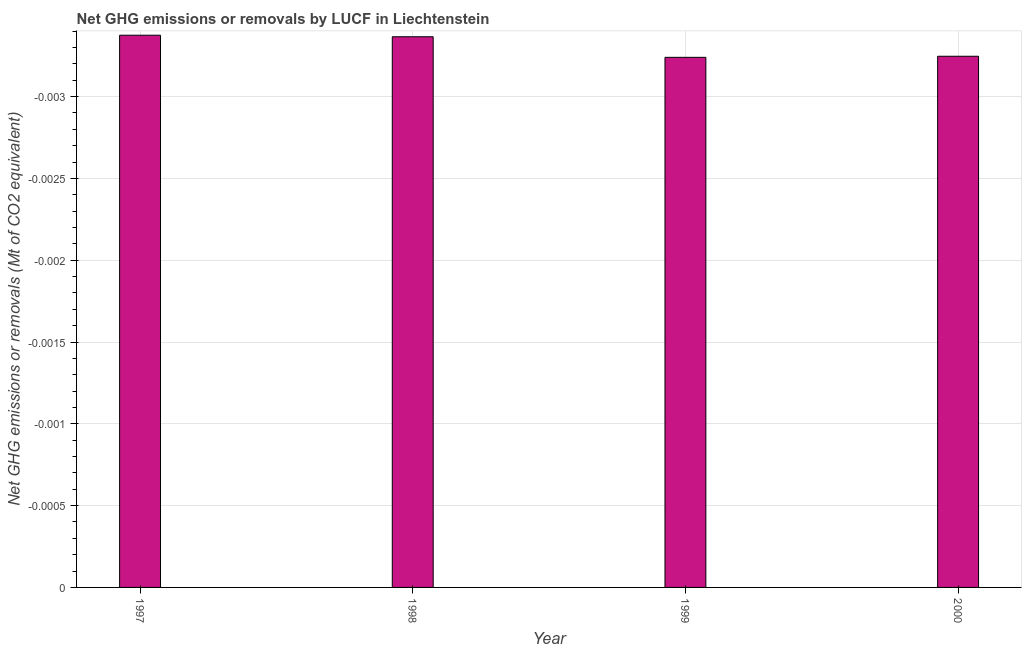Does the graph contain any zero values?
Provide a succinct answer. Yes. Does the graph contain grids?
Provide a short and direct response. Yes. What is the title of the graph?
Keep it short and to the point. Net GHG emissions or removals by LUCF in Liechtenstein. What is the label or title of the Y-axis?
Provide a succinct answer. Net GHG emissions or removals (Mt of CO2 equivalent). What is the ghg net emissions or removals in 1999?
Ensure brevity in your answer.  0. Across all years, what is the minimum ghg net emissions or removals?
Your response must be concise. 0. What is the median ghg net emissions or removals?
Make the answer very short. 0. In how many years, is the ghg net emissions or removals greater than the average ghg net emissions or removals taken over all years?
Give a very brief answer. 0. Are all the bars in the graph horizontal?
Keep it short and to the point. No. What is the difference between two consecutive major ticks on the Y-axis?
Offer a very short reply. 0. What is the Net GHG emissions or removals (Mt of CO2 equivalent) in 1999?
Offer a terse response. 0. What is the Net GHG emissions or removals (Mt of CO2 equivalent) of 2000?
Give a very brief answer. 0. 